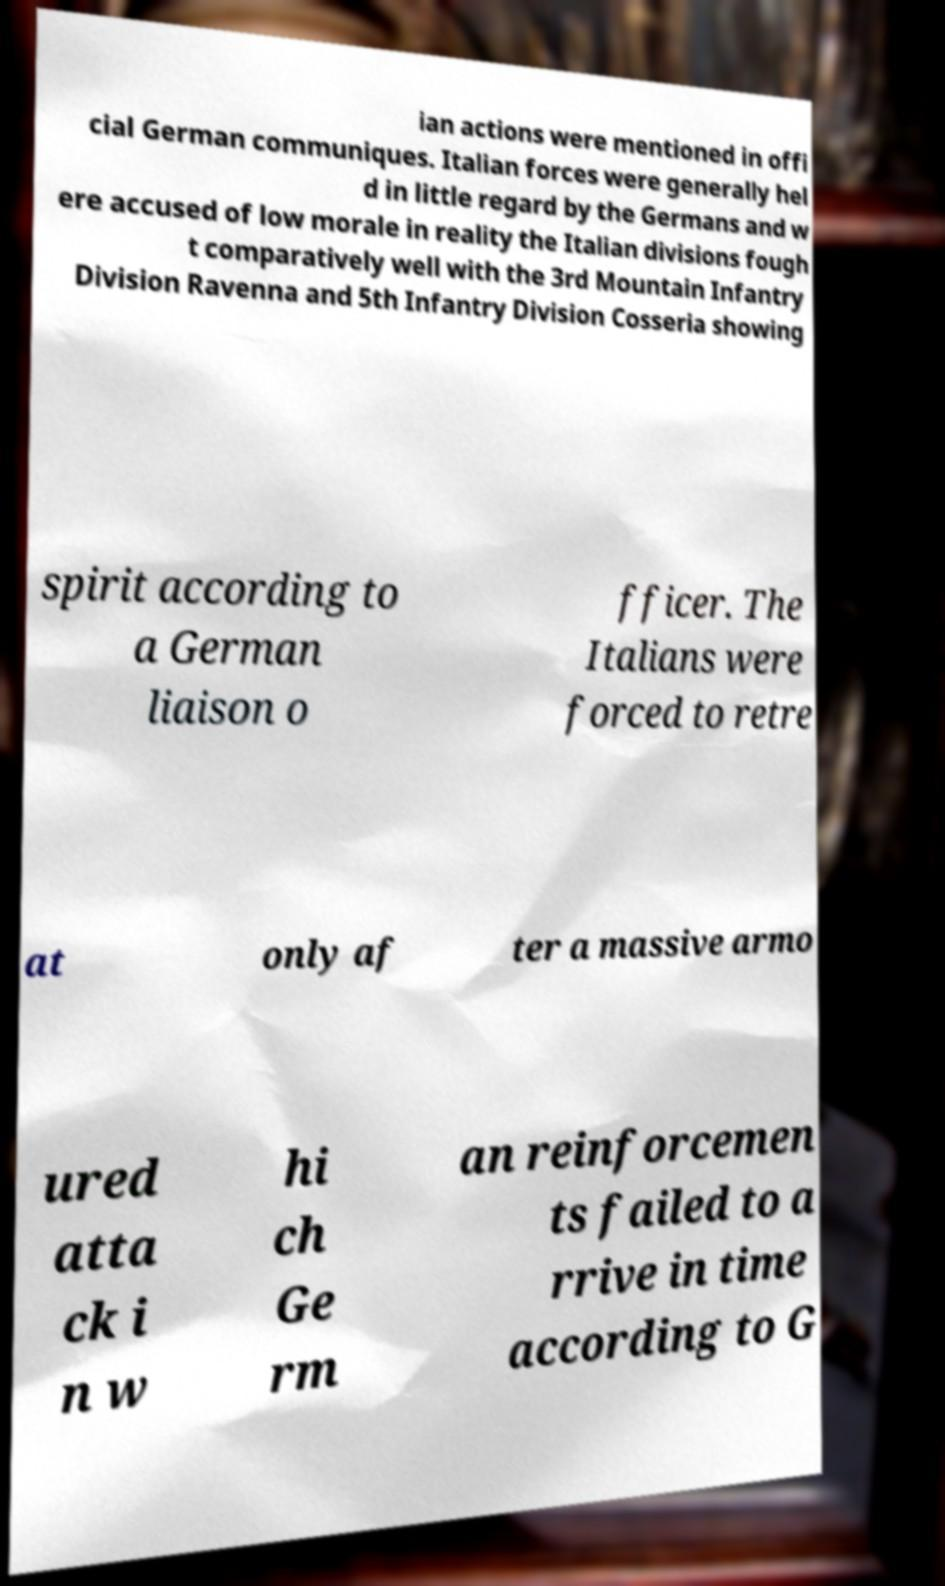Could you assist in decoding the text presented in this image and type it out clearly? ian actions were mentioned in offi cial German communiques. Italian forces were generally hel d in little regard by the Germans and w ere accused of low morale in reality the Italian divisions fough t comparatively well with the 3rd Mountain Infantry Division Ravenna and 5th Infantry Division Cosseria showing spirit according to a German liaison o fficer. The Italians were forced to retre at only af ter a massive armo ured atta ck i n w hi ch Ge rm an reinforcemen ts failed to a rrive in time according to G 